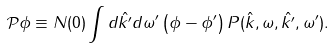Convert formula to latex. <formula><loc_0><loc_0><loc_500><loc_500>\mathcal { P } \phi \equiv N ( 0 ) \int d \hat { k ^ { \prime } } d \omega ^ { \prime } \left ( \phi - \phi ^ { \prime } \right ) P ( \hat { k } , \omega , \hat { k ^ { \prime } } , \omega ^ { \prime } ) .</formula> 